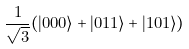Convert formula to latex. <formula><loc_0><loc_0><loc_500><loc_500>\frac { 1 } { \sqrt { 3 } } ( | 0 0 0 \rangle + | 0 1 1 \rangle + | 1 0 1 \rangle )</formula> 